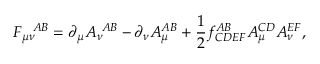<formula> <loc_0><loc_0><loc_500><loc_500>F _ { \mu \nu } ^ { A B } = \partial _ { \mu } A _ { \nu } ^ { A B } - \partial _ { \nu } A _ { \mu } ^ { A B } + \frac { 1 } { 2 } f _ { C D E F } ^ { A B } A _ { \mu } ^ { C D } A _ { \nu } ^ { E F } ,</formula> 